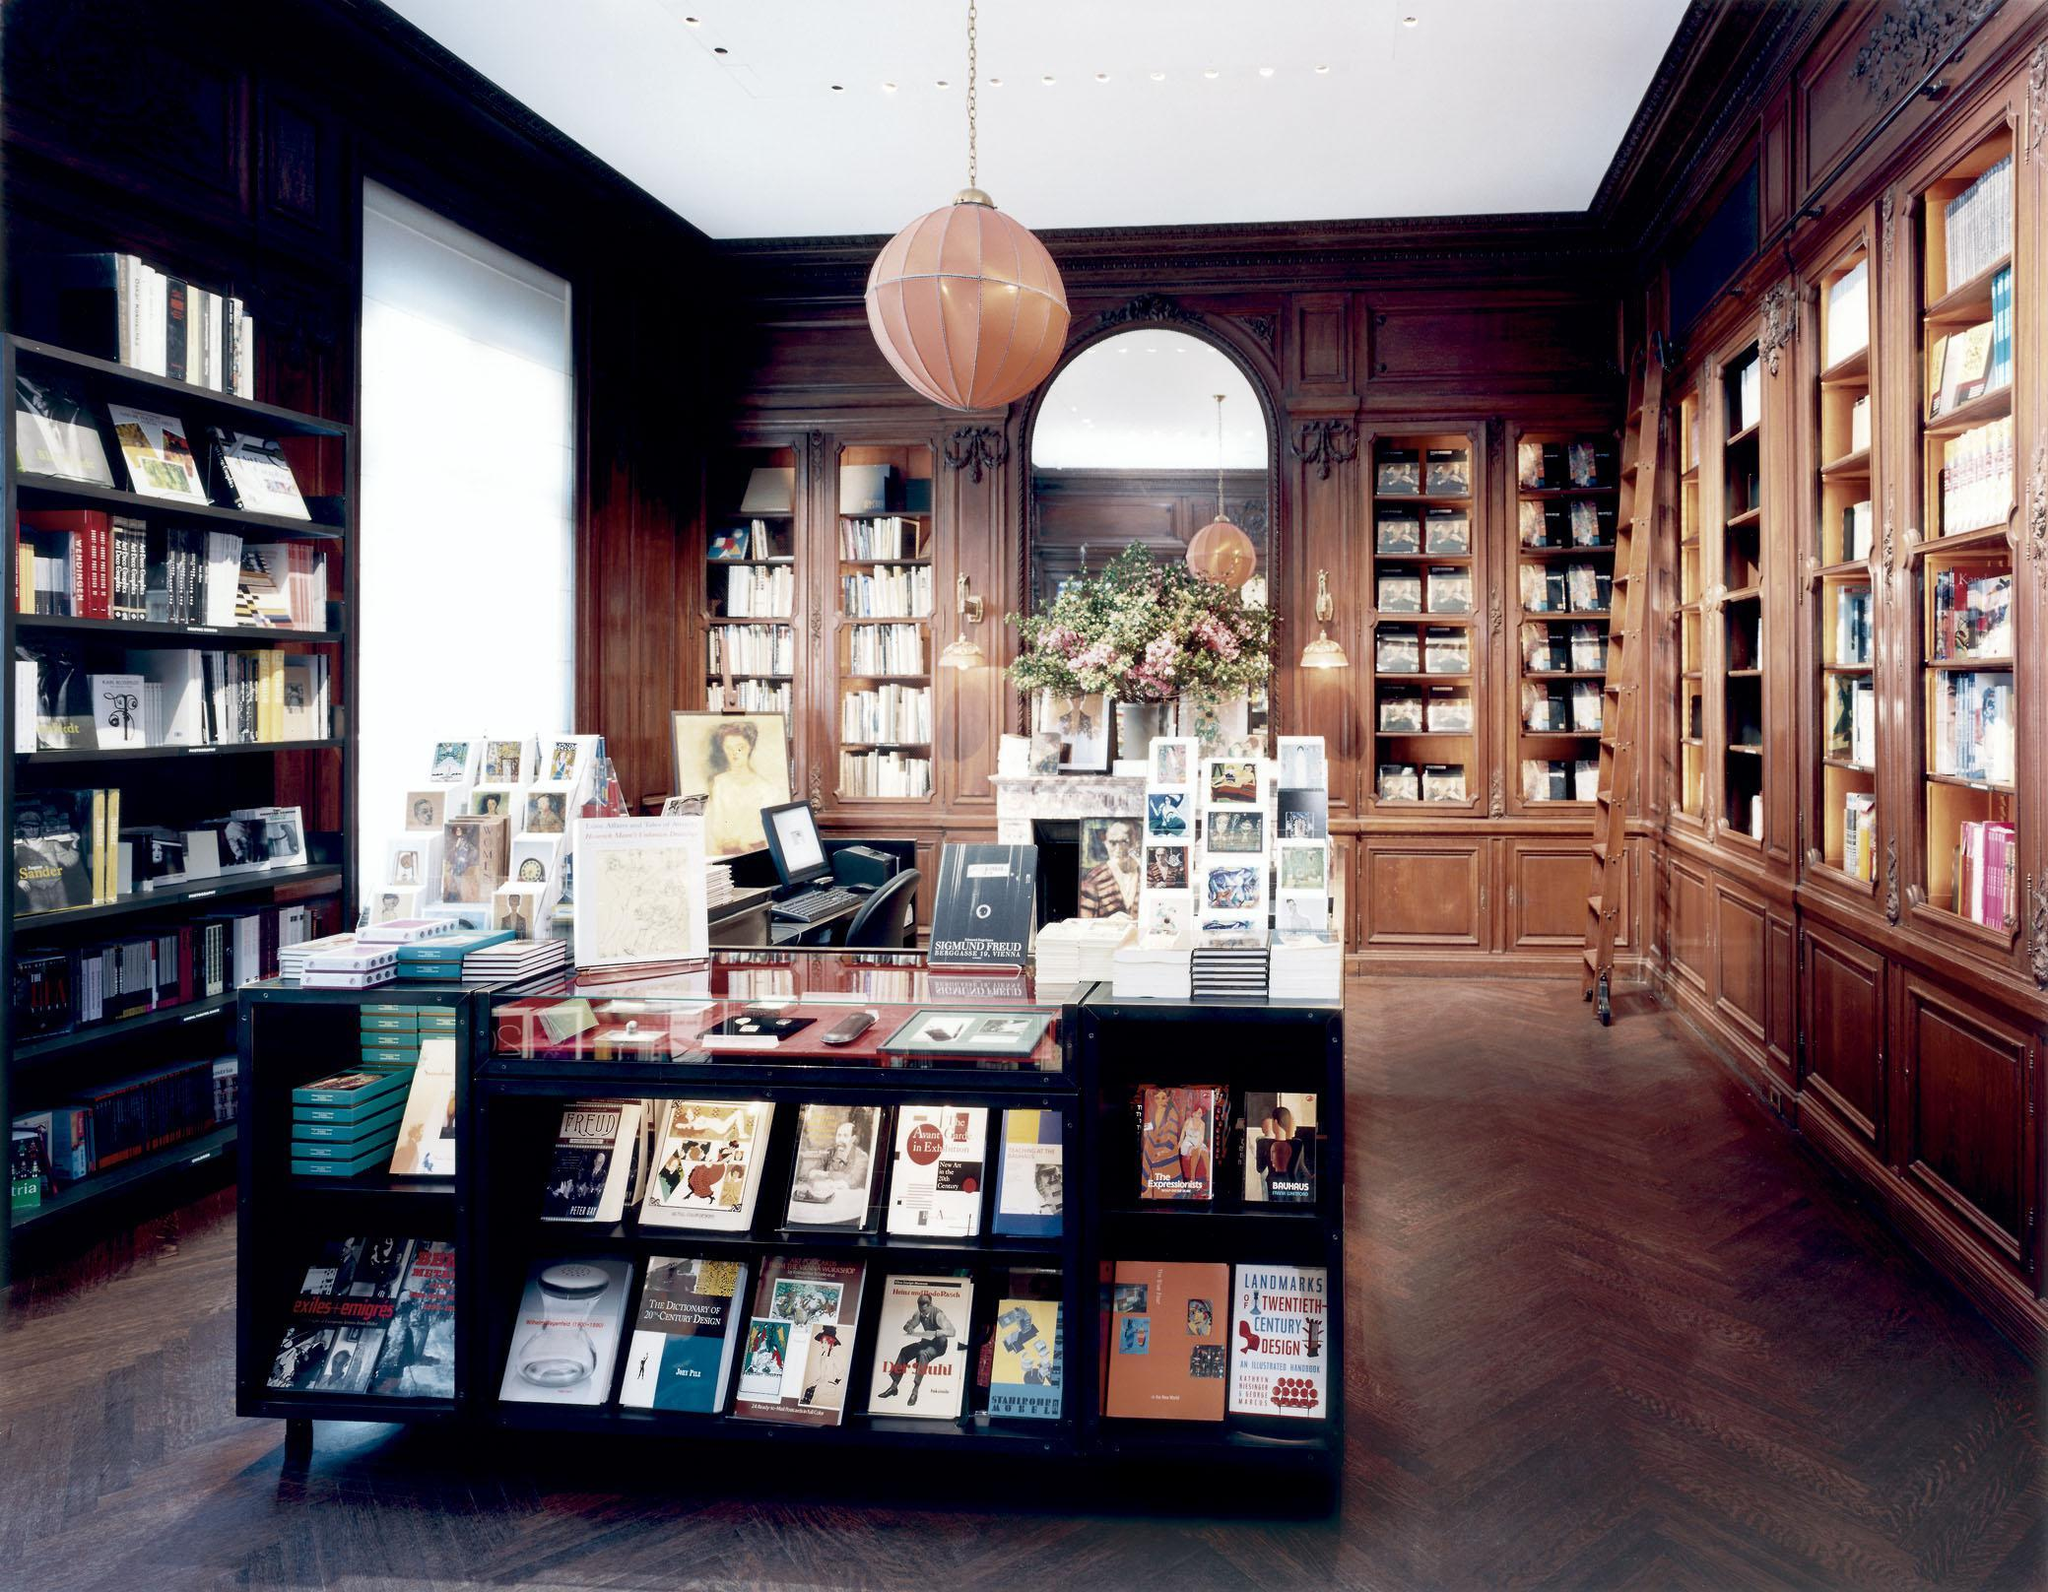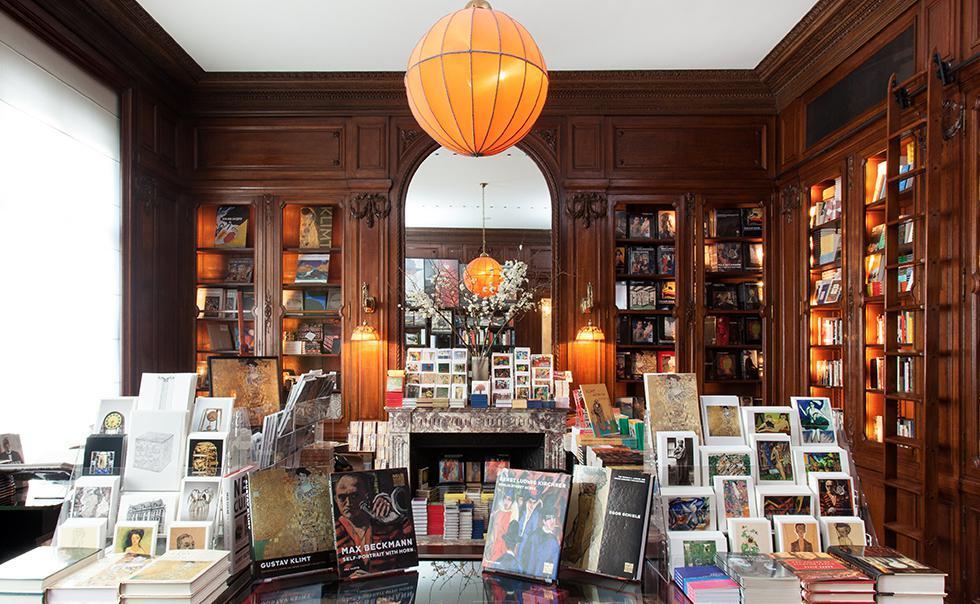The first image is the image on the left, the second image is the image on the right. Evaluate the accuracy of this statement regarding the images: "In at least one image there are two bright orange ball lamps that are on hanging from the ceiling  of either side of an archway". Is it true? Answer yes or no. Yes. The first image is the image on the left, the second image is the image on the right. Given the left and right images, does the statement "At least one image shows an orange ball hanging over a display case and in front of an arch in a room with no people in it." hold true? Answer yes or no. Yes. 